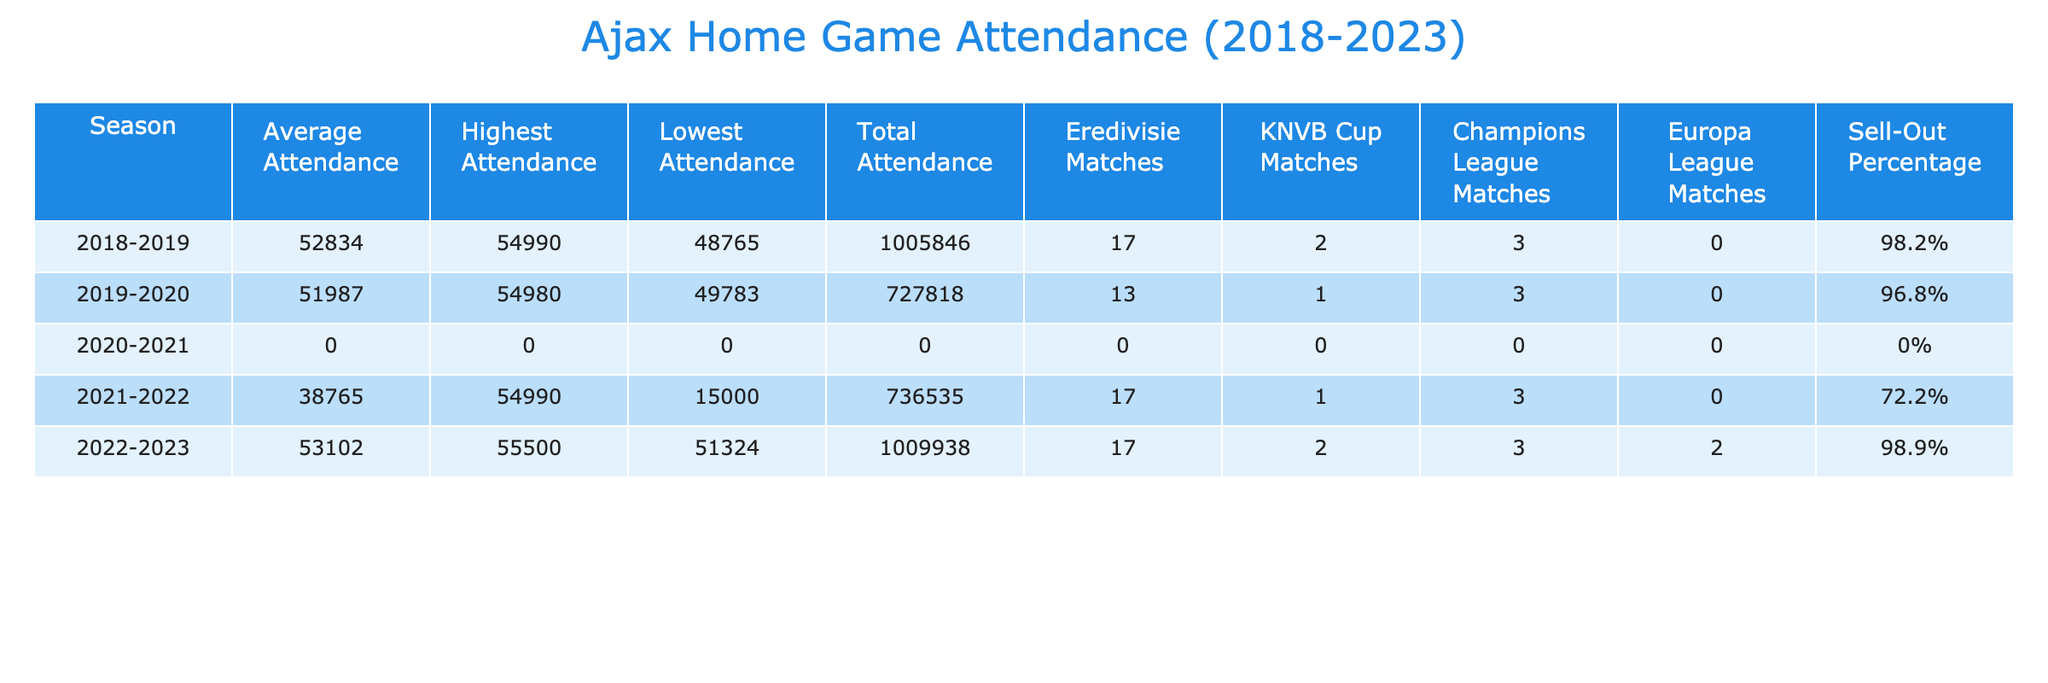What was the highest attendance for Ajax home games during the 2022-2023 season? According to the table, the highest attendance for the 2022-2023 season is listed as 55,500.
Answer: 55,500 What is the average attendance across all seasons in the table? By adding the average attendances: 52,834 + 51,987 + 0 + 38,765 + 53,102 = 196,688. Dividing this by 5 seasons results in an average of 39,337.60, but considering only actual seasons (2018-2019, 2019-2020, 2021-2022, 2022-2023), the contribution to the average is only from 4 seasons: 52,834 + 51,987 + 38,765 + 53,102 = 196,688, which when divided by 4 equals 49,172.
Answer: 49,172 What percentage of matches in the 2021-2022 season were sell-out? The table shows a sell-out percentage of 72.2% for the 2021-2022 season, directly indicating the percentage of matches sold out.
Answer: 72.2% Was the attendance lower in 2020-2021 compared to any other season? The average attendance for the 2020-2021 season is 0, indicating no games were held. Comparing this with all other seasons, all had positive attendance figures, confirming it was lower.
Answer: Yes Which season had the lowest average attendance? The average attendance for the 2020-2021 season is 0, while the lowest for the remaining seasons is 38,765 in 2021-2022. Since 0 is lower than 38,765, 2020-2021 had the lowest.
Answer: 2020-2021 How many total attendances were recorded for the 2018-2019 season? The table states that the total attendance for the 2018-2019 season is 1,005,846.
Answer: 1,005,846 Calculate the difference in total attendance between the 2019-2020 and 2021-2022 seasons. The total attendance for 2019-2020 is 727,818 and for 2021-2022 is 736,535. The difference is 736,535 - 727,818 = 8,717.
Answer: 8,717 Did Ajax play any Europa League matches in the 2022-2023 season? The table indicates that Ajax played two Europa League matches during the 2022-2023 season, affirming their participation in that tournament.
Answer: Yes What was the total attendance for all home games played by Ajax across all seasons? By summing the total attendance figures: 1,005,846 + 727,818 + 0 + 736,535 + 1,009,938 = 2,480,137.
Answer: 2,480,137 Comparing the highest attendances, which season had the most significant capacity reached? The highest attendance recorded across seasons shows 55,500 in 2022-2023, which is the highest figure compared to all other seasons.
Answer: 2022-2023 